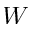Convert formula to latex. <formula><loc_0><loc_0><loc_500><loc_500>W</formula> 